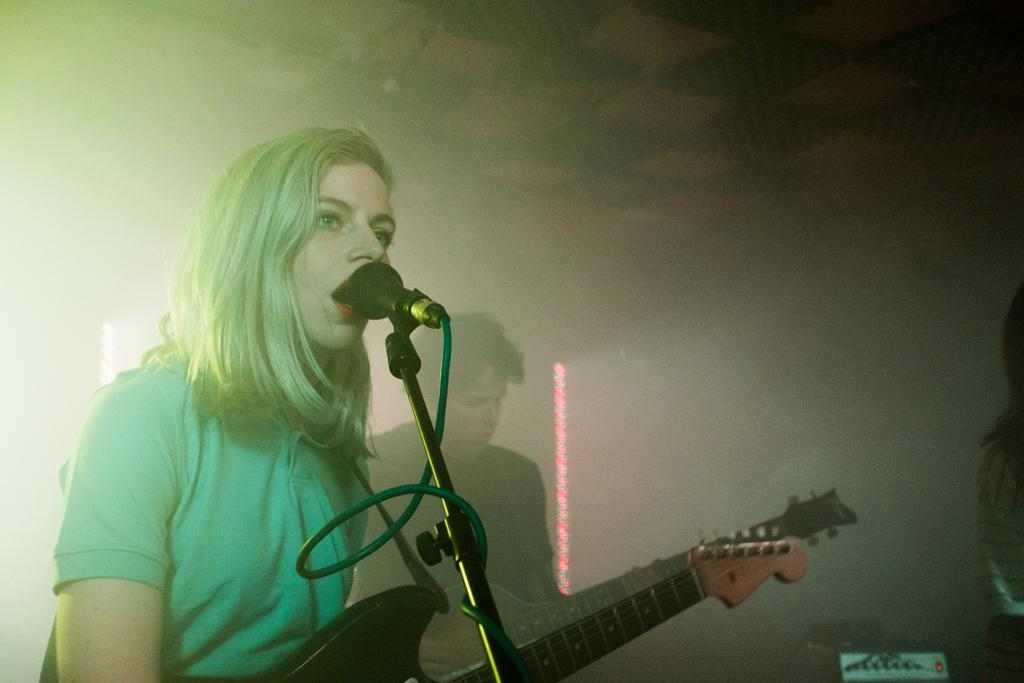How many people are in the image? There are two people in the image. What are the two people doing in the image? The two people are holding guitars and playing them. Can you describe the woman in the image? The woman is singing while using a microphone. What is the woman holding in the image? The woman is holding a microphone to sing. What type of mist can be seen surrounding the glass on the side of the image? There is no mist or glass present in the image; it features two people playing guitars and a woman singing with a microphone. 